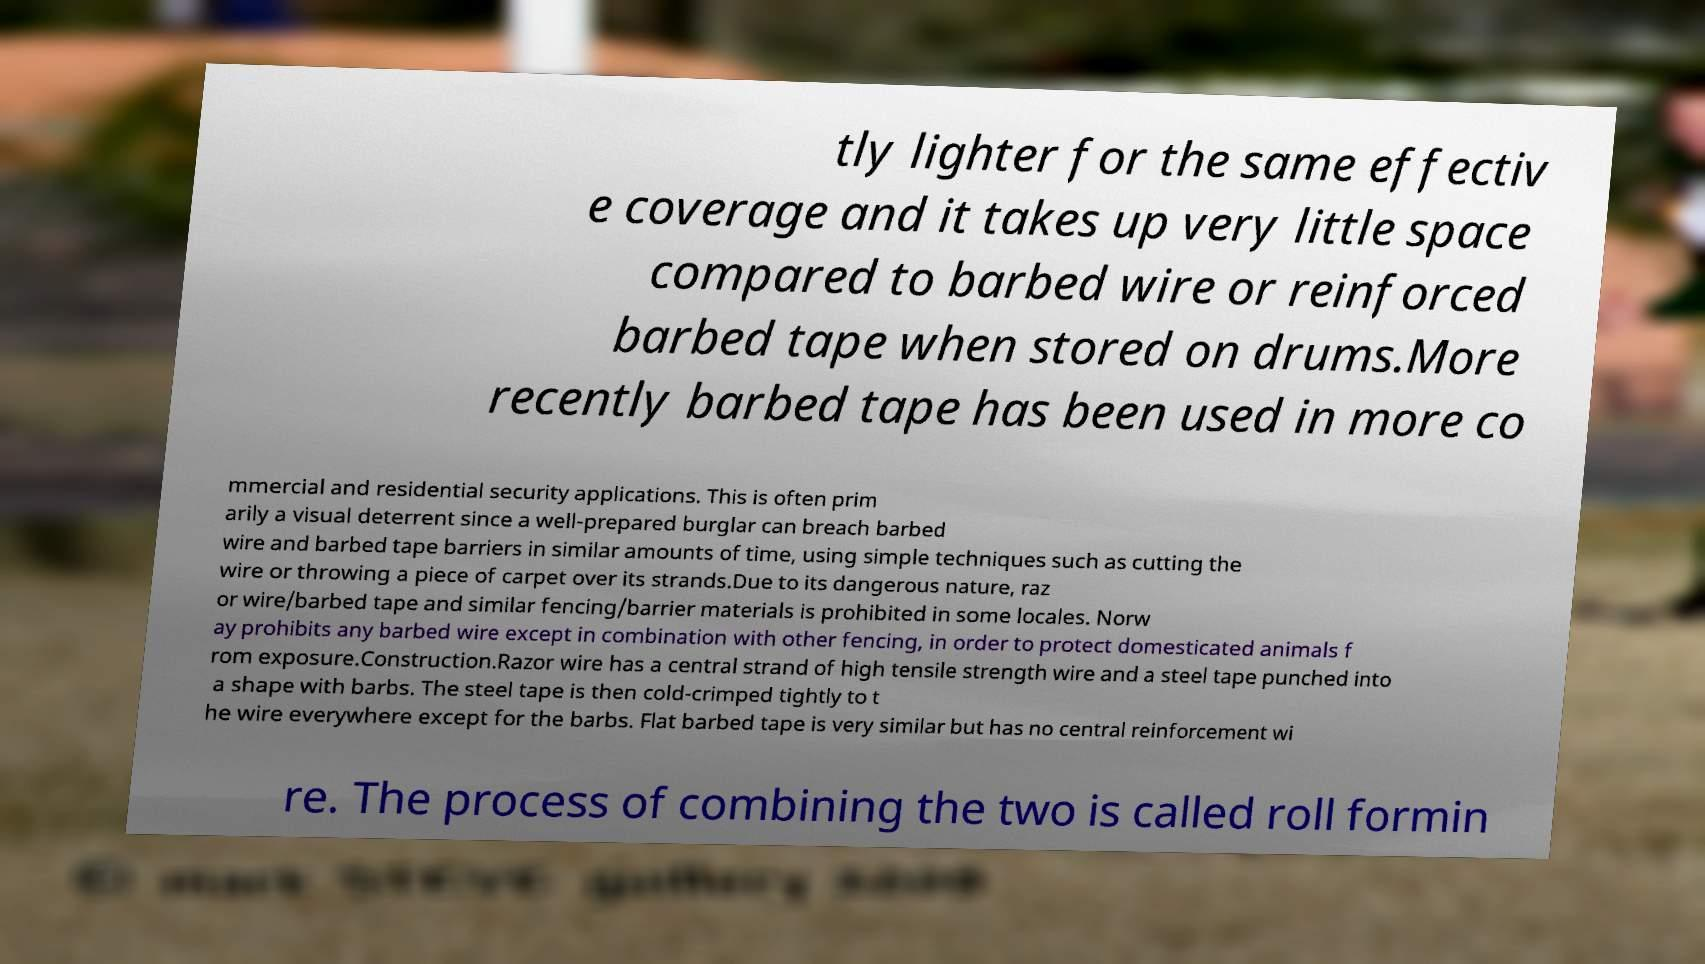I need the written content from this picture converted into text. Can you do that? tly lighter for the same effectiv e coverage and it takes up very little space compared to barbed wire or reinforced barbed tape when stored on drums.More recently barbed tape has been used in more co mmercial and residential security applications. This is often prim arily a visual deterrent since a well-prepared burglar can breach barbed wire and barbed tape barriers in similar amounts of time, using simple techniques such as cutting the wire or throwing a piece of carpet over its strands.Due to its dangerous nature, raz or wire/barbed tape and similar fencing/barrier materials is prohibited in some locales. Norw ay prohibits any barbed wire except in combination with other fencing, in order to protect domesticated animals f rom exposure.Construction.Razor wire has a central strand of high tensile strength wire and a steel tape punched into a shape with barbs. The steel tape is then cold-crimped tightly to t he wire everywhere except for the barbs. Flat barbed tape is very similar but has no central reinforcement wi re. The process of combining the two is called roll formin 